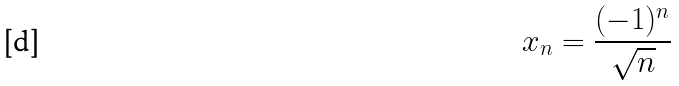Convert formula to latex. <formula><loc_0><loc_0><loc_500><loc_500>x _ { n } = \frac { ( - 1 ) ^ { n } } { \sqrt { n } }</formula> 